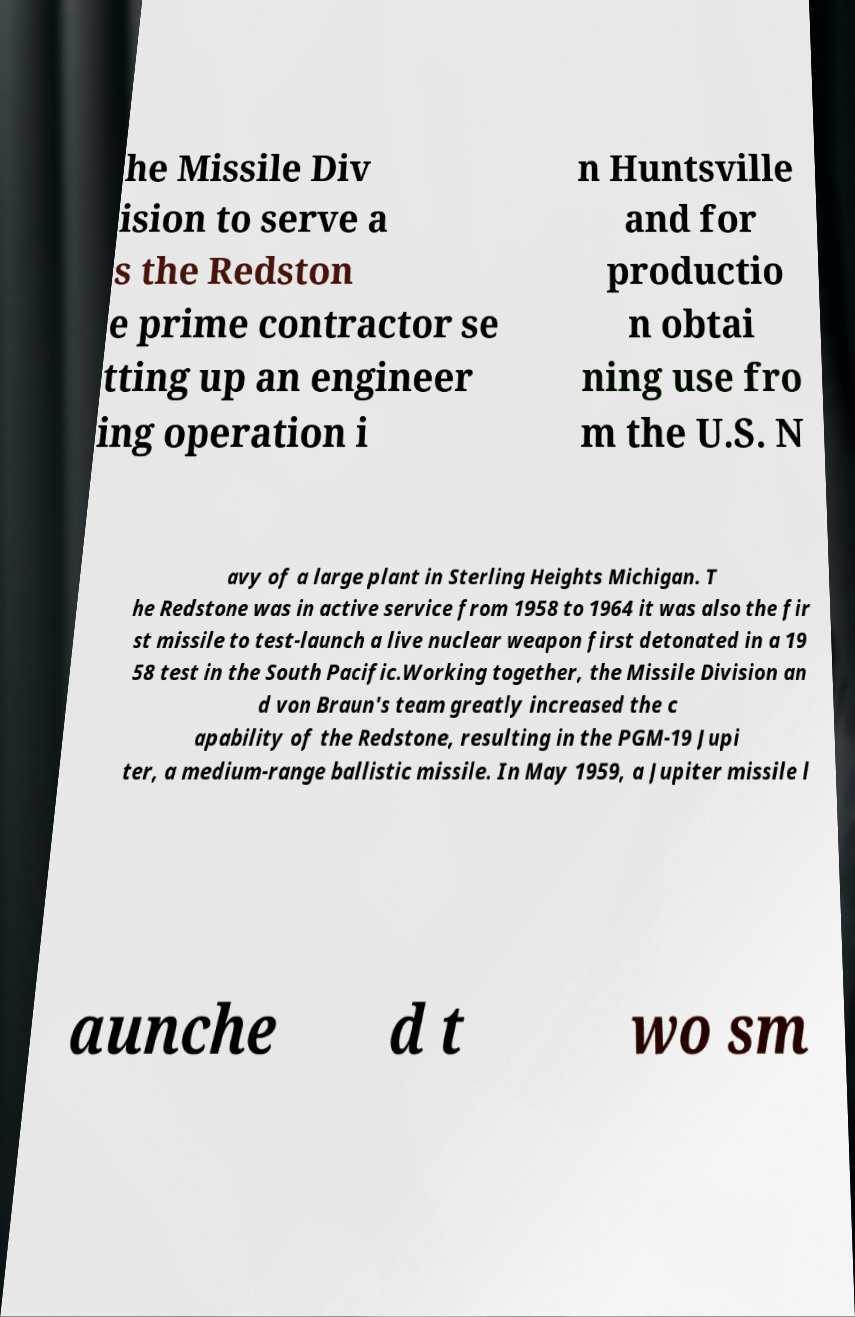Could you assist in decoding the text presented in this image and type it out clearly? he Missile Div ision to serve a s the Redston e prime contractor se tting up an engineer ing operation i n Huntsville and for productio n obtai ning use fro m the U.S. N avy of a large plant in Sterling Heights Michigan. T he Redstone was in active service from 1958 to 1964 it was also the fir st missile to test-launch a live nuclear weapon first detonated in a 19 58 test in the South Pacific.Working together, the Missile Division an d von Braun's team greatly increased the c apability of the Redstone, resulting in the PGM-19 Jupi ter, a medium-range ballistic missile. In May 1959, a Jupiter missile l aunche d t wo sm 